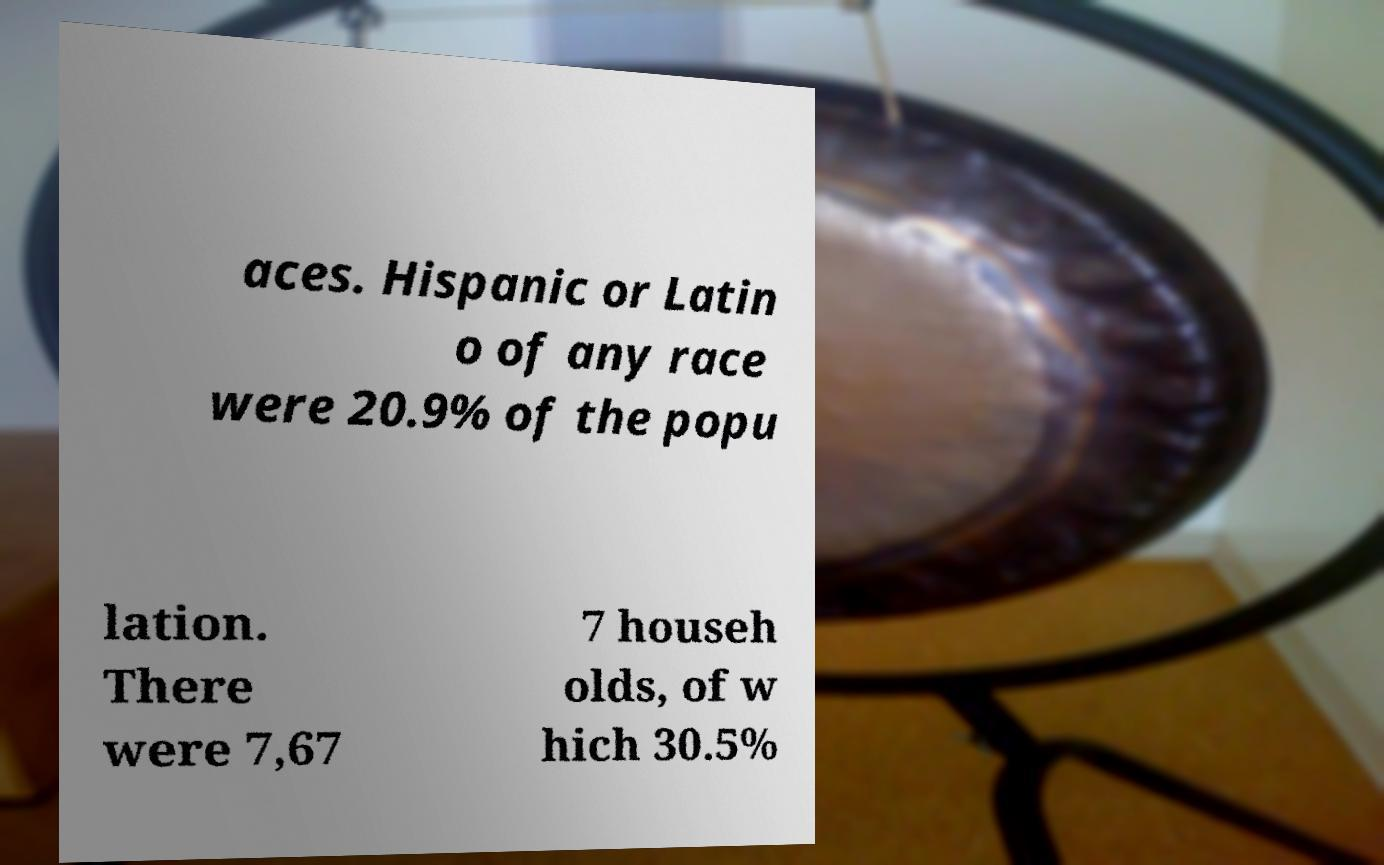Please read and relay the text visible in this image. What does it say? aces. Hispanic or Latin o of any race were 20.9% of the popu lation. There were 7,67 7 househ olds, of w hich 30.5% 